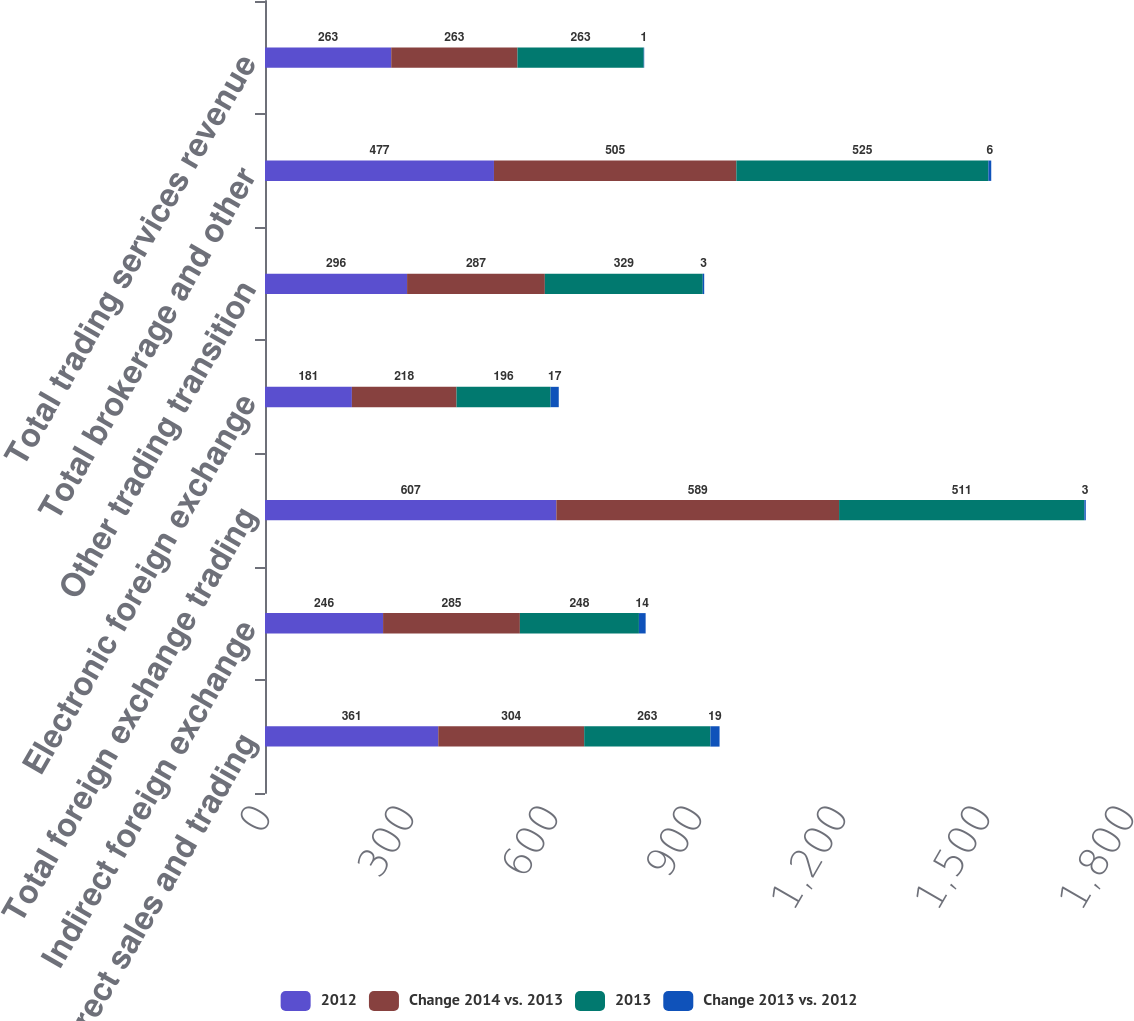Convert chart. <chart><loc_0><loc_0><loc_500><loc_500><stacked_bar_chart><ecel><fcel>Direct sales and trading<fcel>Indirect foreign exchange<fcel>Total foreign exchange trading<fcel>Electronic foreign exchange<fcel>Other trading transition<fcel>Total brokerage and other<fcel>Total trading services revenue<nl><fcel>2012<fcel>361<fcel>246<fcel>607<fcel>181<fcel>296<fcel>477<fcel>263<nl><fcel>Change 2014 vs. 2013<fcel>304<fcel>285<fcel>589<fcel>218<fcel>287<fcel>505<fcel>263<nl><fcel>2013<fcel>263<fcel>248<fcel>511<fcel>196<fcel>329<fcel>525<fcel>263<nl><fcel>Change 2013 vs. 2012<fcel>19<fcel>14<fcel>3<fcel>17<fcel>3<fcel>6<fcel>1<nl></chart> 